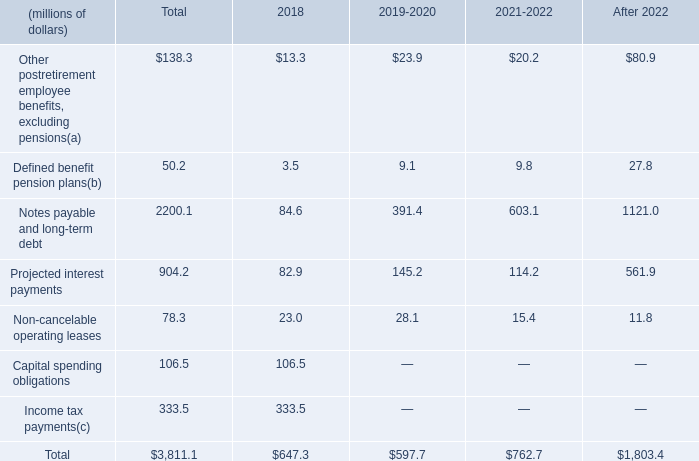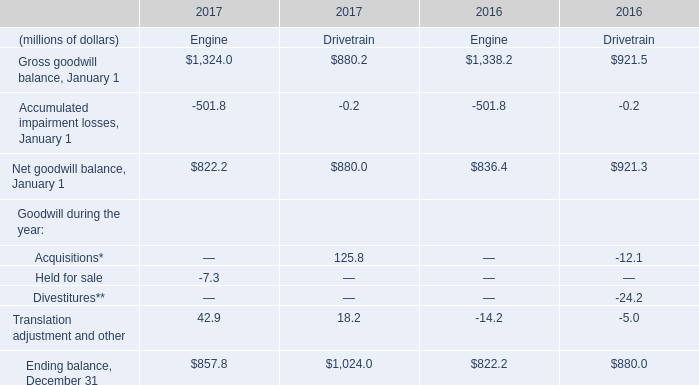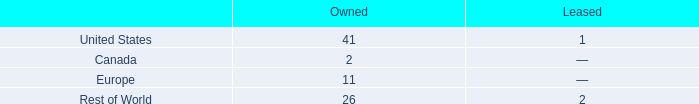what portion of the total facilities is owned by the company? 
Computations: ((((41 + 2) + 11) + 26) / 83)
Answer: 0.96386. 